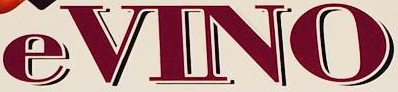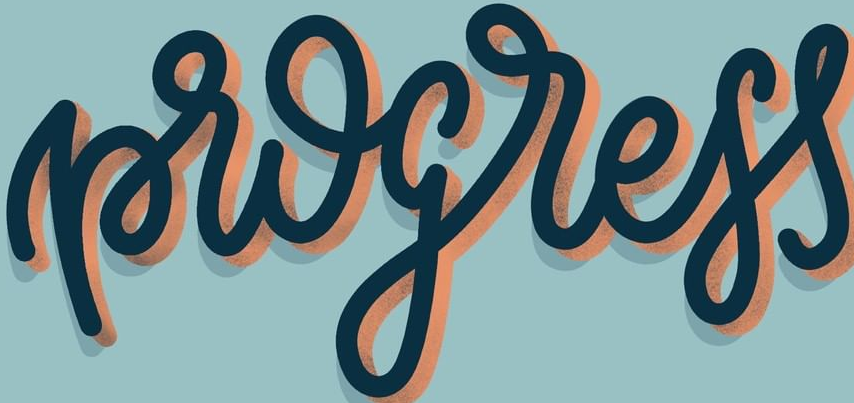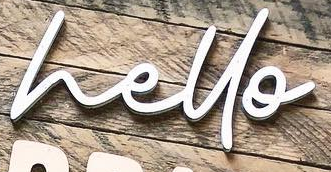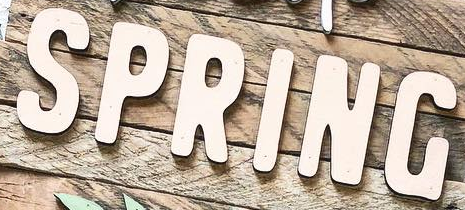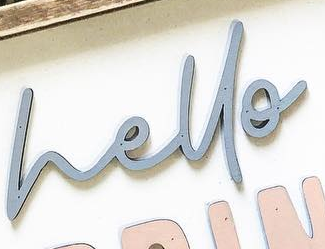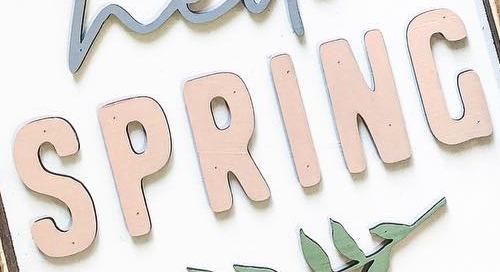Transcribe the words shown in these images in order, separated by a semicolon. eVINO; progress; hello; SPRING; hello; SPRING 